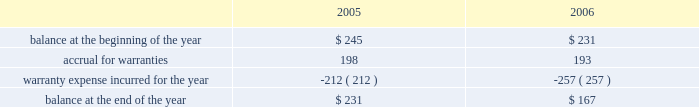Abiomed , inc .
And subsidiaries notes to consolidated financial statements 2014 ( continued ) evidence of an arrangement exists , ( 2 ) delivery has occurred or services have been rendered , ( 3 ) the seller 2019s price to the buyer is fixed or determinable , and ( 4 ) collectibility is reasonably assured .
Further , sab 104 requires that both title and the risks and rewards of ownership be transferred to the buyer before revenue can be recognized .
In addition to sab 104 , we follow the guidance of eitf 00-21 , revenue arrangements with multiple deliverables .
We derive our revenues primarily from product sales , including maintenance service agreements .
The great majority of our product revenues are derived from shipments of our ab5000 and bvs 5000 product lines to fulfill customer orders for a specified number of consoles and/or blood pumps for a specified price .
We recognize revenues and record costs related to such sales upon product shipment .
Maintenance and service support contract revenues are recognized ratably over the term of the service contracts based upon the elapsed term of the service contract .
Government-sponsored research and development contracts and grants generally provide for payment on a cost-plus-fixed-fee basis .
Revenues from these contracts and grants are recognized as work is performed , provided the government has appropriated sufficient funds for the work .
Under contracts in which the company elects to spend significantly more on the development project during the term of the contract than the total contract amount , the company prospectively recognizes revenue on such contracts ratably over the term of the contract as it incurs related research and development costs , provided the government has appropriated sufficient funds for the work .
( d ) translation of foreign currencies all assets and liabilities of the company 2019s non-u.s .
Subsidiaries are translated at year-end exchange rates , and revenues and expenses are translated at average exchange rates for the year in accordance with sfas no .
52 , foreign currency translation .
Resulting translation adjustments are reflected in the accumulated other comprehensive loss component of shareholders 2019 equity .
Currency transaction gains and losses are included in the accompanying statement of income and are not material for the three years presented .
( e ) warranties the company routinely accrues for estimated future warranty costs on its product sales at the time of sale .
Our products are subject to rigorous regulation and quality standards .
Warranty costs are included in cost of product revenues within the consolidated statements of operations .
The table summarizes the activities in the warranty reserve for the two fiscal years ended march 31 , 2006 ( in thousands ) .

What was the change in thousands of the warranty expense incurred for the year from 2005 to 2006? 
Computations: (257 - 212)
Answer: 45.0. 